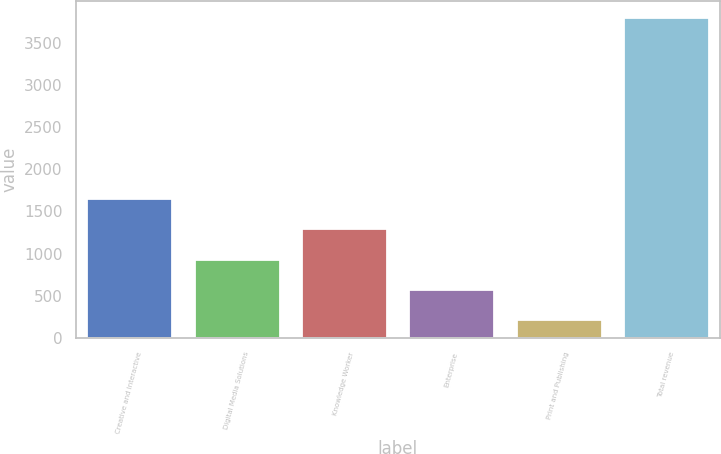<chart> <loc_0><loc_0><loc_500><loc_500><bar_chart><fcel>Creative and Interactive<fcel>Digital Media Solutions<fcel>Knowledge Worker<fcel>Enterprise<fcel>Print and Publishing<fcel>Total revenue<nl><fcel>1655.72<fcel>940.96<fcel>1298.34<fcel>583.58<fcel>226.2<fcel>3800<nl></chart> 